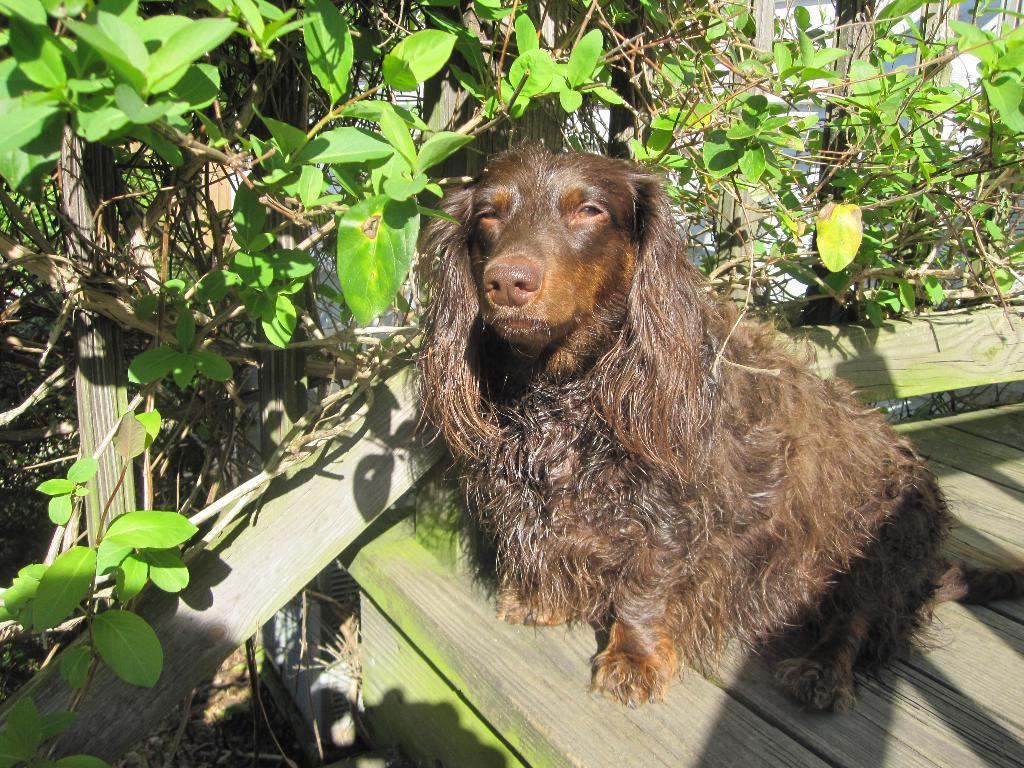What type of animal is in the image? The type of animal cannot be determined from the provided facts. What is the animal sitting on or near in the image? There is a wooden table in the image. What celestial bodies are visible at the top of the image? Planets are visible at the top of the image. What substance is being sold on the street in the image? There is no street or substance being sold present in the image. How many people can be seen interacting with the animal in the image? There is no person present in the image. 